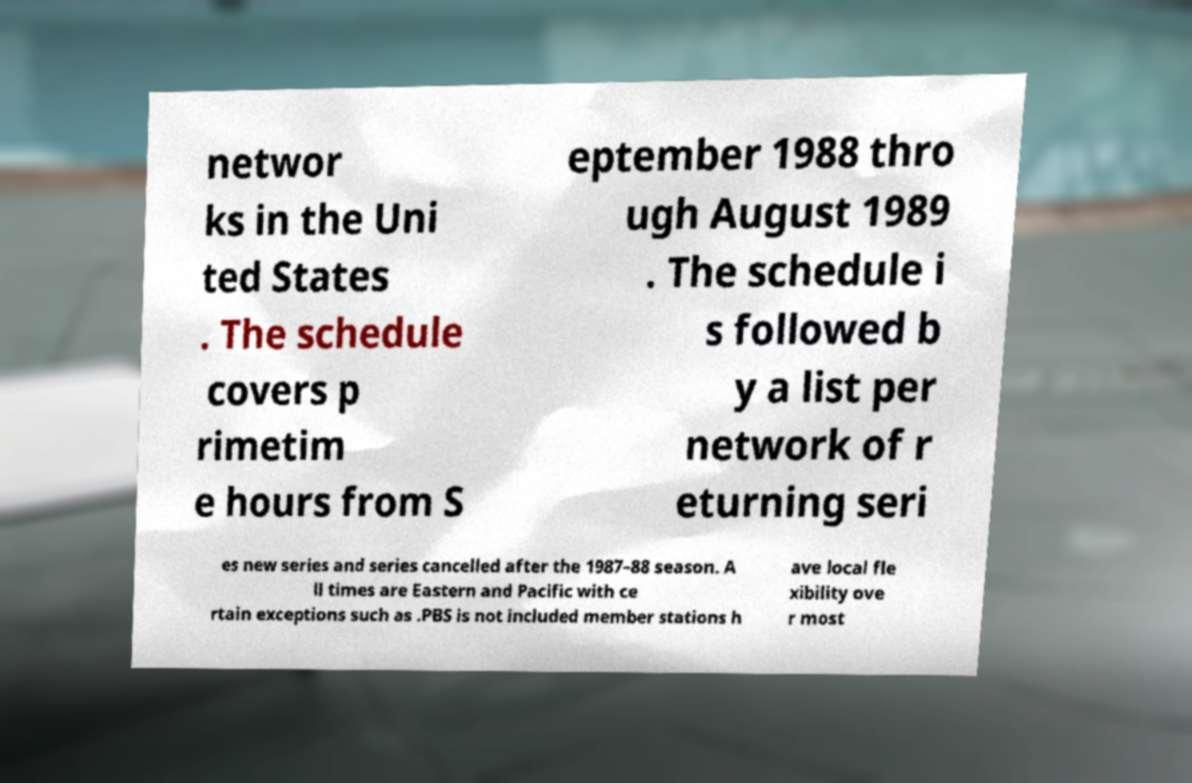Could you extract and type out the text from this image? networ ks in the Uni ted States . The schedule covers p rimetim e hours from S eptember 1988 thro ugh August 1989 . The schedule i s followed b y a list per network of r eturning seri es new series and series cancelled after the 1987–88 season. A ll times are Eastern and Pacific with ce rtain exceptions such as .PBS is not included member stations h ave local fle xibility ove r most 